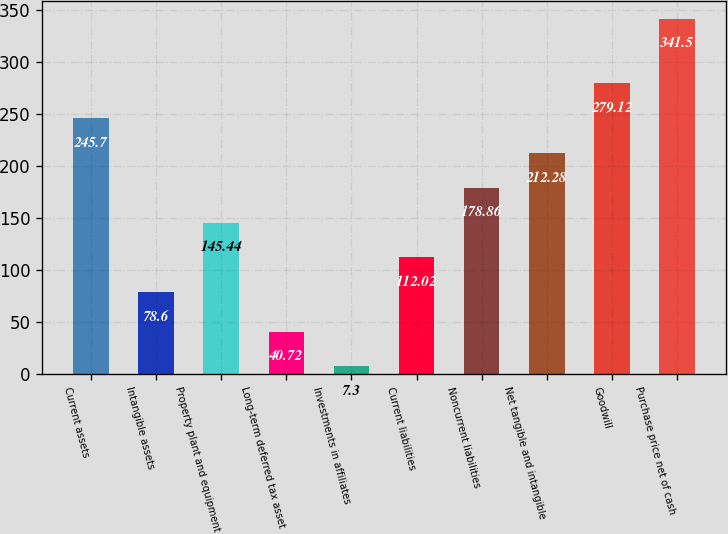Convert chart. <chart><loc_0><loc_0><loc_500><loc_500><bar_chart><fcel>Current assets<fcel>Intangible assets<fcel>Property plant and equipment<fcel>Long-term deferred tax asset<fcel>Investments in affiliates<fcel>Current liabilities<fcel>Noncurrent liabilities<fcel>Net tangible and intangible<fcel>Goodwill<fcel>Purchase price net of cash<nl><fcel>245.7<fcel>78.6<fcel>145.44<fcel>40.72<fcel>7.3<fcel>112.02<fcel>178.86<fcel>212.28<fcel>279.12<fcel>341.5<nl></chart> 